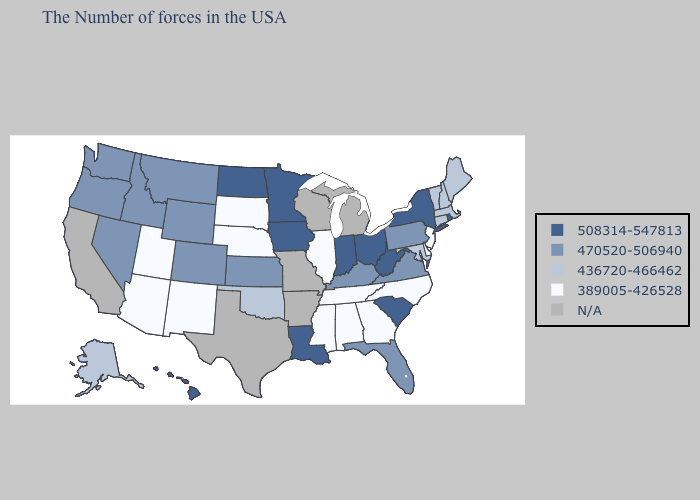What is the value of Idaho?
Keep it brief. 470520-506940. What is the highest value in the USA?
Quick response, please. 508314-547813. What is the lowest value in the USA?
Write a very short answer. 389005-426528. Does Tennessee have the lowest value in the South?
Give a very brief answer. Yes. Which states have the highest value in the USA?
Concise answer only. Rhode Island, New York, South Carolina, West Virginia, Ohio, Indiana, Louisiana, Minnesota, Iowa, North Dakota, Hawaii. Does South Carolina have the lowest value in the USA?
Be succinct. No. Which states have the lowest value in the USA?
Concise answer only. New Jersey, Delaware, North Carolina, Georgia, Alabama, Tennessee, Illinois, Mississippi, Nebraska, South Dakota, New Mexico, Utah, Arizona. Does the first symbol in the legend represent the smallest category?
Keep it brief. No. Which states hav the highest value in the West?
Be succinct. Hawaii. Which states have the highest value in the USA?
Keep it brief. Rhode Island, New York, South Carolina, West Virginia, Ohio, Indiana, Louisiana, Minnesota, Iowa, North Dakota, Hawaii. What is the lowest value in the MidWest?
Keep it brief. 389005-426528. Among the states that border Utah , which have the lowest value?
Keep it brief. New Mexico, Arizona. Name the states that have a value in the range 470520-506940?
Quick response, please. Pennsylvania, Virginia, Florida, Kentucky, Kansas, Wyoming, Colorado, Montana, Idaho, Nevada, Washington, Oregon. 